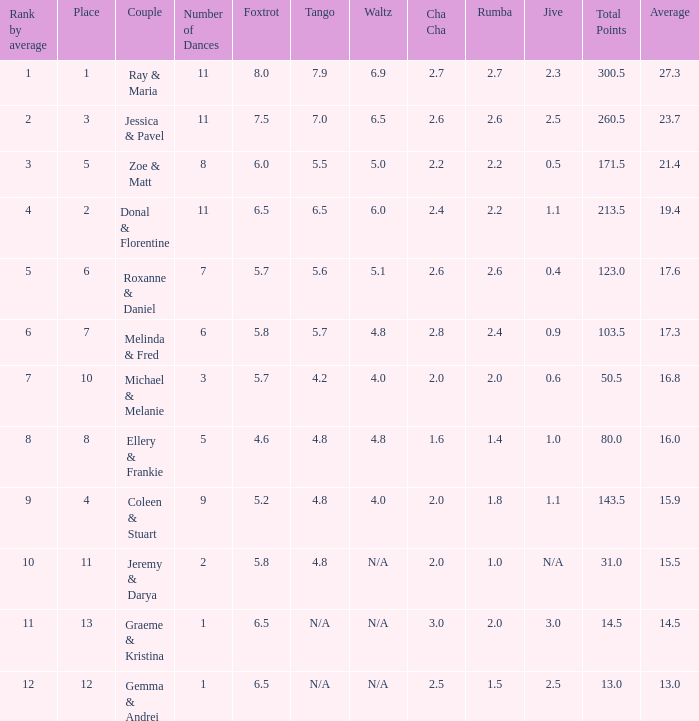What place would you be in if your rank by average is less than 2.0? 1.0. 